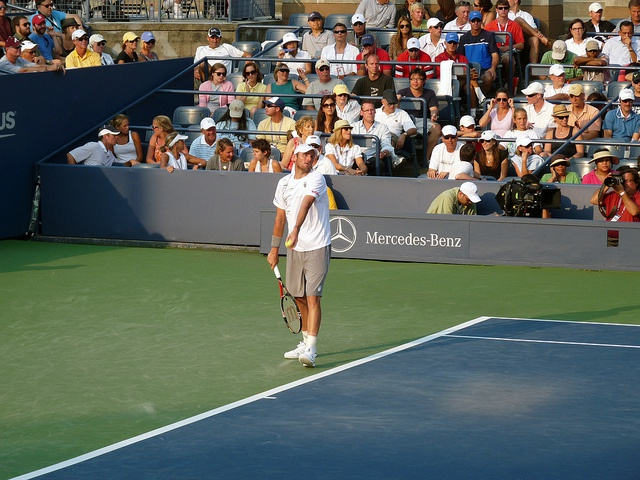Describe the objects in this image and their specific colors. I can see people in black, gray, and lightgray tones, chair in black, white, gray, and darkgray tones, people in black, white, darkgray, gray, and tan tones, people in black, maroon, gray, and blue tones, and people in black, white, tan, brown, and gray tones in this image. 